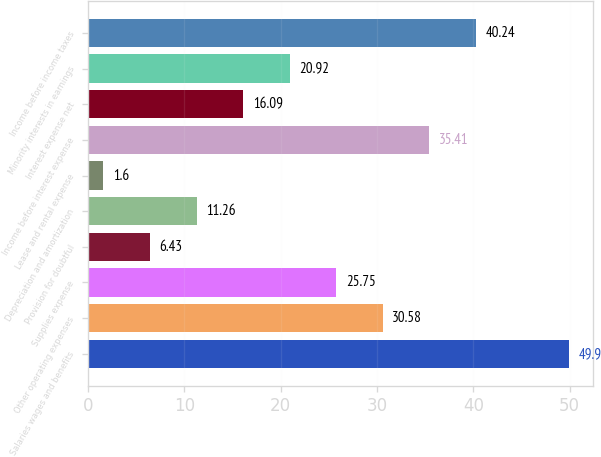Convert chart to OTSL. <chart><loc_0><loc_0><loc_500><loc_500><bar_chart><fcel>Salaries wages and benefits<fcel>Other operating expenses<fcel>Supplies expense<fcel>Provision for doubtful<fcel>Depreciation and amortization<fcel>Lease and rental expense<fcel>Income before interest expense<fcel>Interest expense net<fcel>Minority interests in earnings<fcel>Income before income taxes<nl><fcel>49.9<fcel>30.58<fcel>25.75<fcel>6.43<fcel>11.26<fcel>1.6<fcel>35.41<fcel>16.09<fcel>20.92<fcel>40.24<nl></chart> 